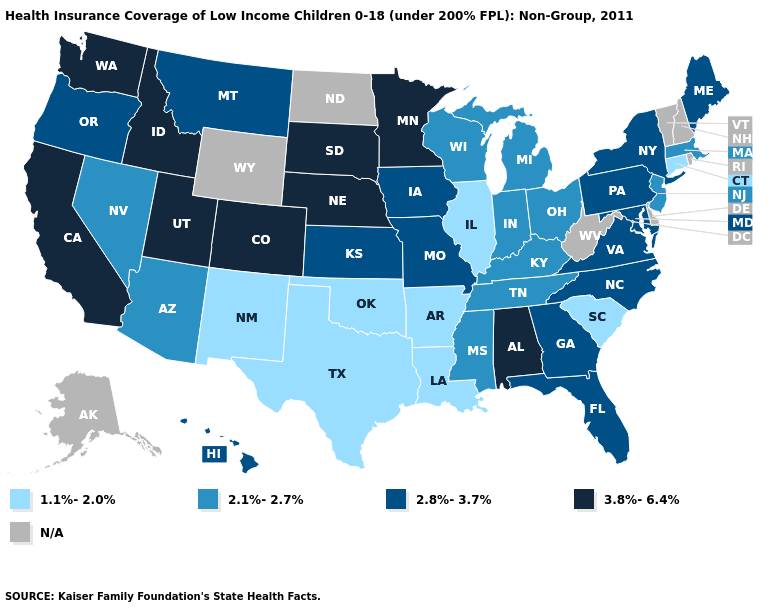Name the states that have a value in the range 2.1%-2.7%?
Short answer required. Arizona, Indiana, Kentucky, Massachusetts, Michigan, Mississippi, Nevada, New Jersey, Ohio, Tennessee, Wisconsin. Name the states that have a value in the range 2.1%-2.7%?
Short answer required. Arizona, Indiana, Kentucky, Massachusetts, Michigan, Mississippi, Nevada, New Jersey, Ohio, Tennessee, Wisconsin. Name the states that have a value in the range 3.8%-6.4%?
Keep it brief. Alabama, California, Colorado, Idaho, Minnesota, Nebraska, South Dakota, Utah, Washington. Name the states that have a value in the range 1.1%-2.0%?
Answer briefly. Arkansas, Connecticut, Illinois, Louisiana, New Mexico, Oklahoma, South Carolina, Texas. Does the first symbol in the legend represent the smallest category?
Keep it brief. Yes. Name the states that have a value in the range 2.1%-2.7%?
Answer briefly. Arizona, Indiana, Kentucky, Massachusetts, Michigan, Mississippi, Nevada, New Jersey, Ohio, Tennessee, Wisconsin. Does Alabama have the highest value in the USA?
Quick response, please. Yes. Which states have the lowest value in the USA?
Answer briefly. Arkansas, Connecticut, Illinois, Louisiana, New Mexico, Oklahoma, South Carolina, Texas. Name the states that have a value in the range 3.8%-6.4%?
Keep it brief. Alabama, California, Colorado, Idaho, Minnesota, Nebraska, South Dakota, Utah, Washington. Name the states that have a value in the range 2.1%-2.7%?
Short answer required. Arizona, Indiana, Kentucky, Massachusetts, Michigan, Mississippi, Nevada, New Jersey, Ohio, Tennessee, Wisconsin. What is the value of Massachusetts?
Answer briefly. 2.1%-2.7%. 